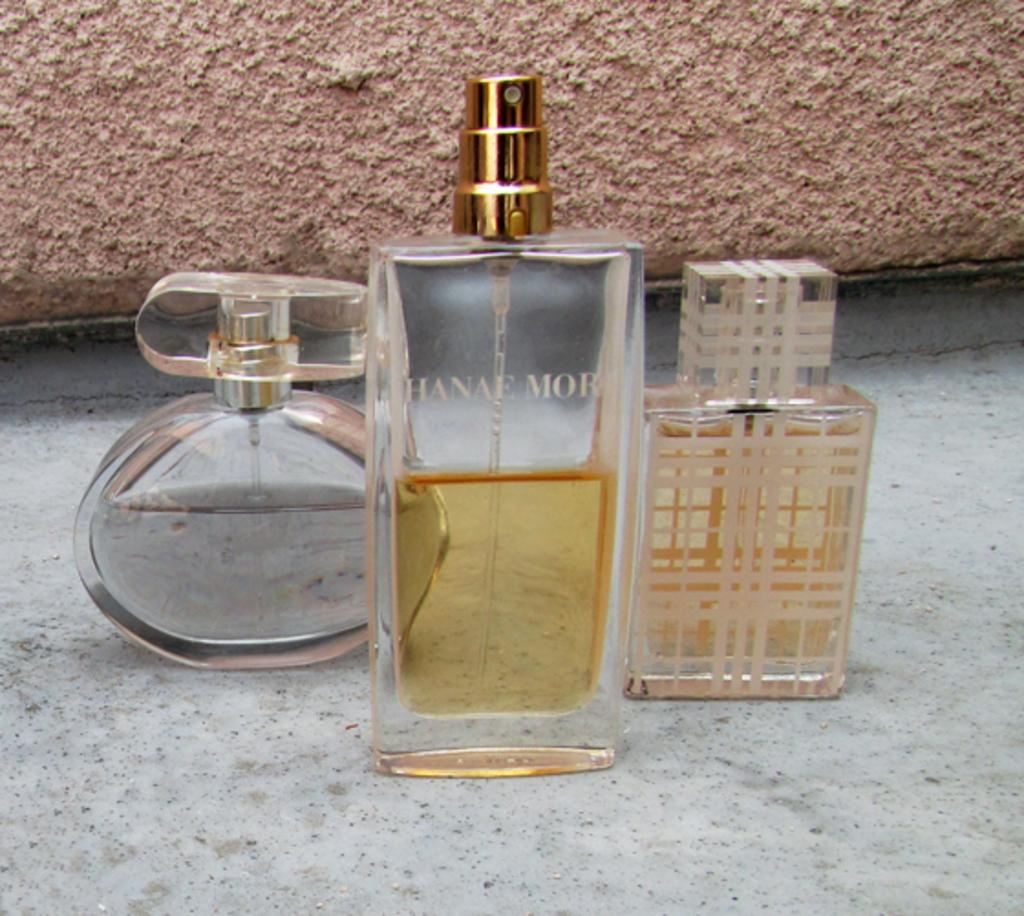<image>
Give a short and clear explanation of the subsequent image. three bottles of perfume on a marble floor including Hanae MOR 